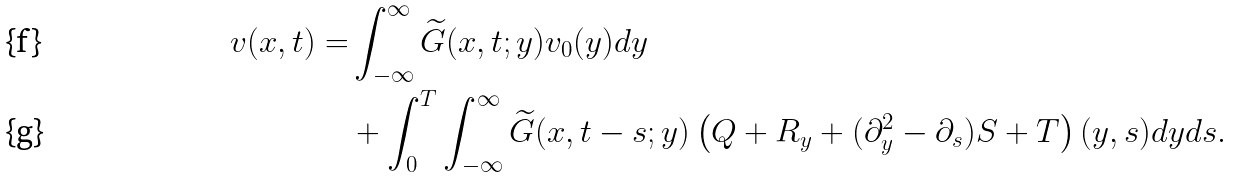<formula> <loc_0><loc_0><loc_500><loc_500>v ( x , t ) = & \int _ { - \infty } ^ { \infty } \widetilde { G } ( x , t ; y ) v _ { 0 } ( y ) d y \\ & + \int _ { 0 } ^ { T } \int _ { - \infty } ^ { \infty } \widetilde { G } ( x , t - s ; y ) \left ( Q + R _ { y } + ( \partial _ { y } ^ { 2 } - \partial _ { s } ) S + T \right ) ( y , s ) d y d s .</formula> 